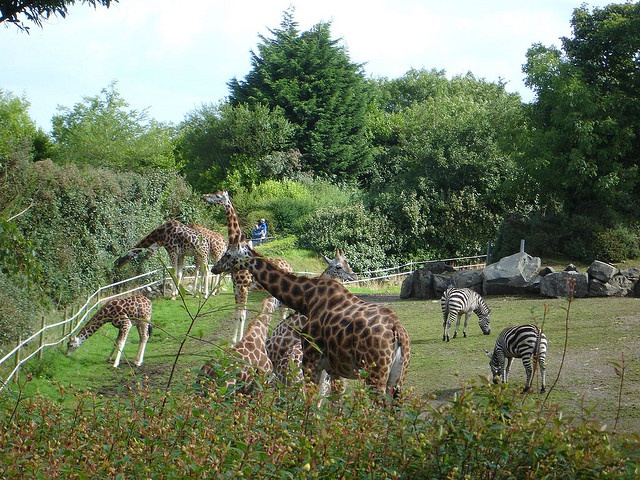Describe the objects in this image and their specific colors. I can see giraffe in black, gray, and maroon tones, giraffe in black, darkgreen, gray, and tan tones, giraffe in black, gray, darkgreen, and darkgray tones, giraffe in black, gray, tan, and olive tones, and giraffe in black, gray, darkgreen, and darkgray tones in this image. 